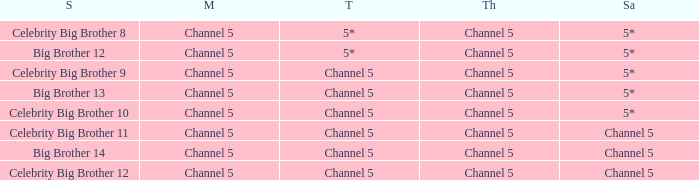Which series airs Saturday on Channel 5? Celebrity Big Brother 11, Big Brother 14, Celebrity Big Brother 12. 